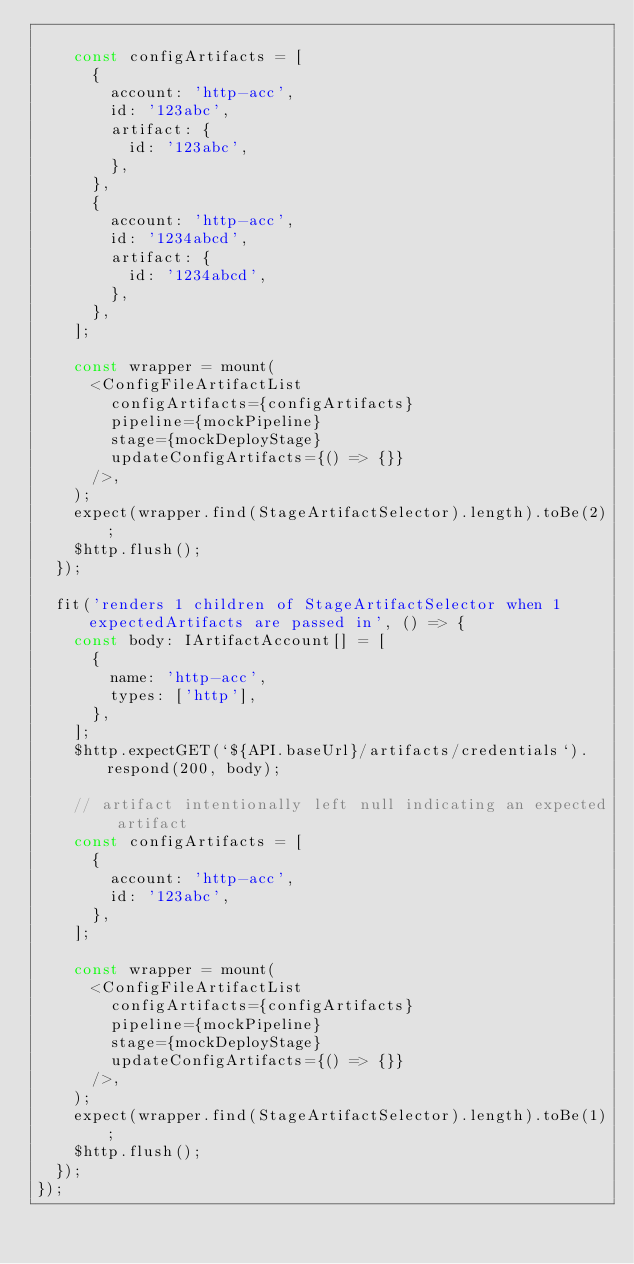Convert code to text. <code><loc_0><loc_0><loc_500><loc_500><_TypeScript_>
    const configArtifacts = [
      {
        account: 'http-acc',
        id: '123abc',
        artifact: {
          id: '123abc',
        },
      },
      {
        account: 'http-acc',
        id: '1234abcd',
        artifact: {
          id: '1234abcd',
        },
      },
    ];

    const wrapper = mount(
      <ConfigFileArtifactList
        configArtifacts={configArtifacts}
        pipeline={mockPipeline}
        stage={mockDeployStage}
        updateConfigArtifacts={() => {}}
      />,
    );
    expect(wrapper.find(StageArtifactSelector).length).toBe(2);
    $http.flush();
  });

  fit('renders 1 children of StageArtifactSelector when 1 expectedArtifacts are passed in', () => {
    const body: IArtifactAccount[] = [
      {
        name: 'http-acc',
        types: ['http'],
      },
    ];
    $http.expectGET(`${API.baseUrl}/artifacts/credentials`).respond(200, body);

    // artifact intentionally left null indicating an expected artifact
    const configArtifacts = [
      {
        account: 'http-acc',
        id: '123abc',
      },
    ];

    const wrapper = mount(
      <ConfigFileArtifactList
        configArtifacts={configArtifacts}
        pipeline={mockPipeline}
        stage={mockDeployStage}
        updateConfigArtifacts={() => {}}
      />,
    );
    expect(wrapper.find(StageArtifactSelector).length).toBe(1);
    $http.flush();
  });
});
</code> 